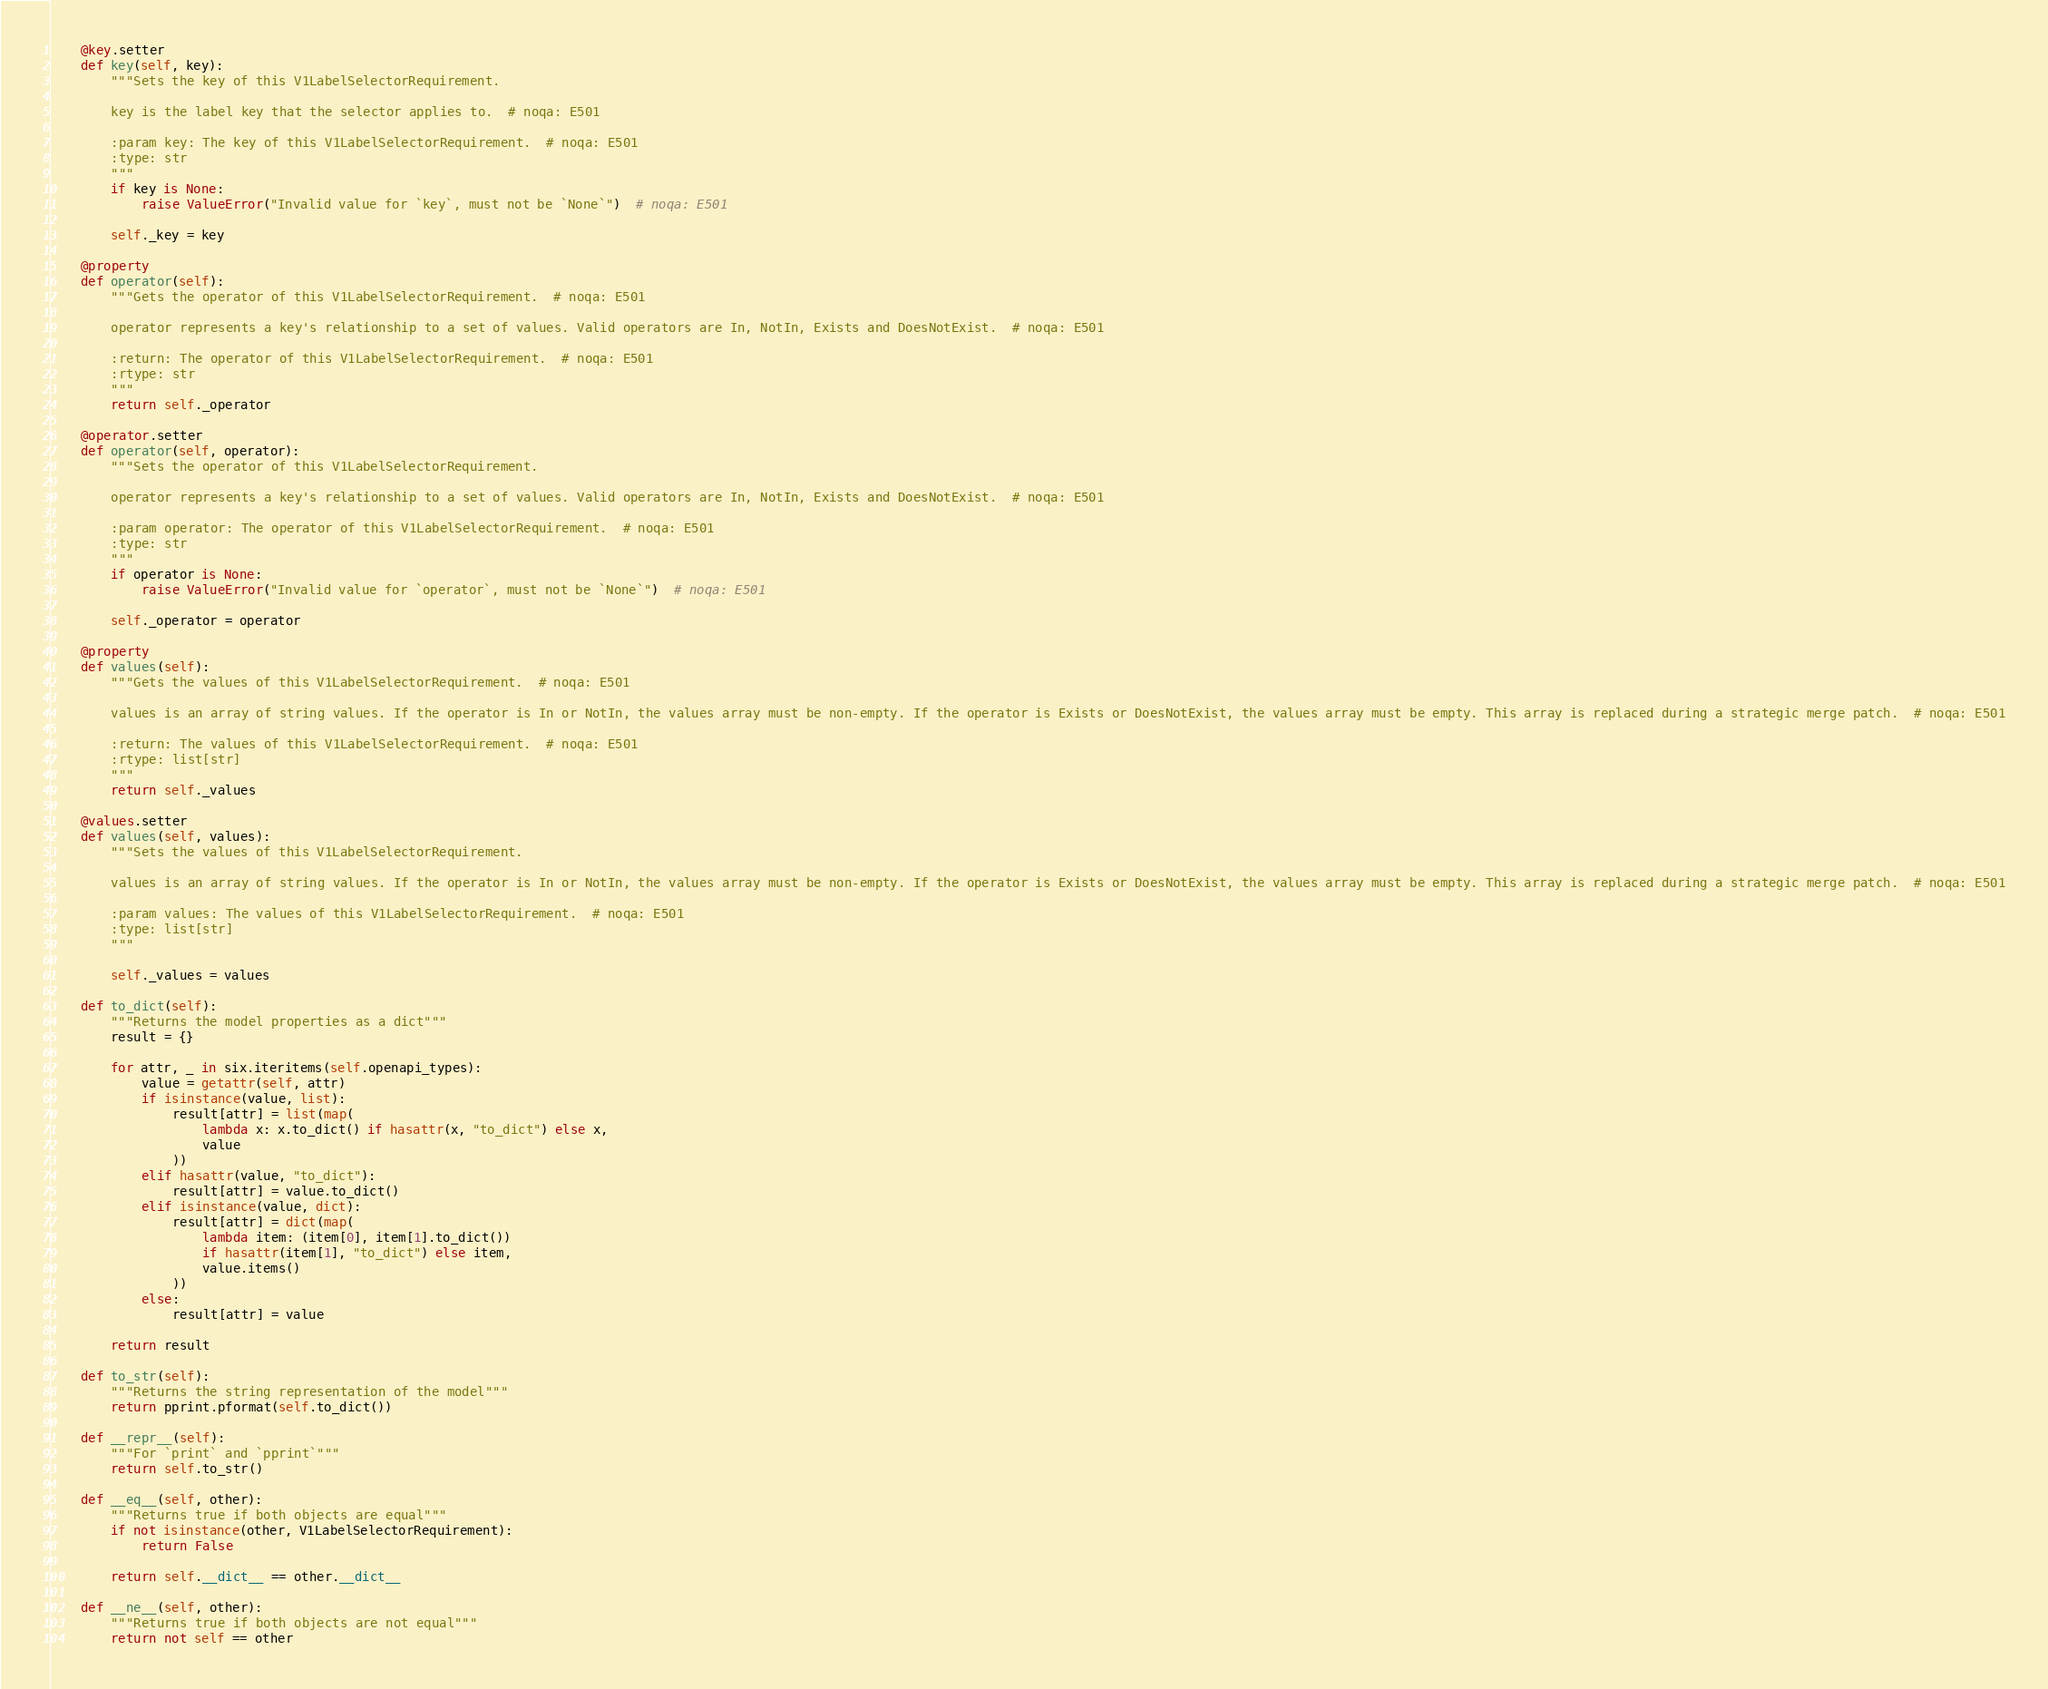Convert code to text. <code><loc_0><loc_0><loc_500><loc_500><_Python_>    @key.setter
    def key(self, key):
        """Sets the key of this V1LabelSelectorRequirement.

        key is the label key that the selector applies to.  # noqa: E501

        :param key: The key of this V1LabelSelectorRequirement.  # noqa: E501
        :type: str
        """
        if key is None:
            raise ValueError("Invalid value for `key`, must not be `None`")  # noqa: E501

        self._key = key

    @property
    def operator(self):
        """Gets the operator of this V1LabelSelectorRequirement.  # noqa: E501

        operator represents a key's relationship to a set of values. Valid operators are In, NotIn, Exists and DoesNotExist.  # noqa: E501

        :return: The operator of this V1LabelSelectorRequirement.  # noqa: E501
        :rtype: str
        """
        return self._operator

    @operator.setter
    def operator(self, operator):
        """Sets the operator of this V1LabelSelectorRequirement.

        operator represents a key's relationship to a set of values. Valid operators are In, NotIn, Exists and DoesNotExist.  # noqa: E501

        :param operator: The operator of this V1LabelSelectorRequirement.  # noqa: E501
        :type: str
        """
        if operator is None:
            raise ValueError("Invalid value for `operator`, must not be `None`")  # noqa: E501

        self._operator = operator

    @property
    def values(self):
        """Gets the values of this V1LabelSelectorRequirement.  # noqa: E501

        values is an array of string values. If the operator is In or NotIn, the values array must be non-empty. If the operator is Exists or DoesNotExist, the values array must be empty. This array is replaced during a strategic merge patch.  # noqa: E501

        :return: The values of this V1LabelSelectorRequirement.  # noqa: E501
        :rtype: list[str]
        """
        return self._values

    @values.setter
    def values(self, values):
        """Sets the values of this V1LabelSelectorRequirement.

        values is an array of string values. If the operator is In or NotIn, the values array must be non-empty. If the operator is Exists or DoesNotExist, the values array must be empty. This array is replaced during a strategic merge patch.  # noqa: E501

        :param values: The values of this V1LabelSelectorRequirement.  # noqa: E501
        :type: list[str]
        """

        self._values = values

    def to_dict(self):
        """Returns the model properties as a dict"""
        result = {}

        for attr, _ in six.iteritems(self.openapi_types):
            value = getattr(self, attr)
            if isinstance(value, list):
                result[attr] = list(map(
                    lambda x: x.to_dict() if hasattr(x, "to_dict") else x,
                    value
                ))
            elif hasattr(value, "to_dict"):
                result[attr] = value.to_dict()
            elif isinstance(value, dict):
                result[attr] = dict(map(
                    lambda item: (item[0], item[1].to_dict())
                    if hasattr(item[1], "to_dict") else item,
                    value.items()
                ))
            else:
                result[attr] = value

        return result

    def to_str(self):
        """Returns the string representation of the model"""
        return pprint.pformat(self.to_dict())

    def __repr__(self):
        """For `print` and `pprint`"""
        return self.to_str()

    def __eq__(self, other):
        """Returns true if both objects are equal"""
        if not isinstance(other, V1LabelSelectorRequirement):
            return False

        return self.__dict__ == other.__dict__

    def __ne__(self, other):
        """Returns true if both objects are not equal"""
        return not self == other
</code> 